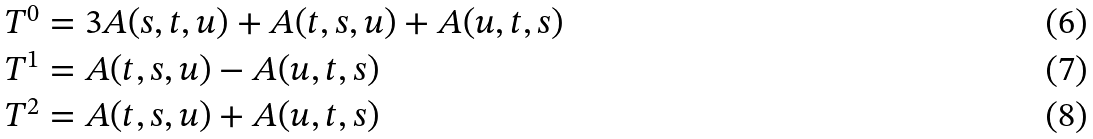Convert formula to latex. <formula><loc_0><loc_0><loc_500><loc_500>T ^ { 0 } & = 3 A ( s , t , u ) + A ( t , s , u ) + A ( u , t , s ) \\ T ^ { 1 } & = A ( t , s , u ) - A ( u , t , s ) \\ T ^ { 2 } & = A ( t , s , u ) + A ( u , t , s )</formula> 